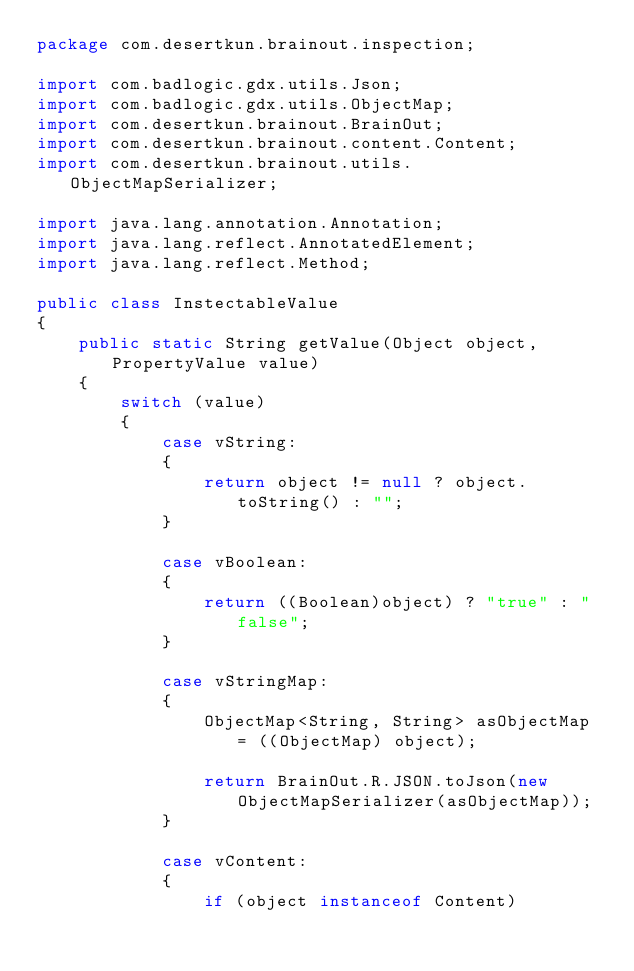<code> <loc_0><loc_0><loc_500><loc_500><_Java_>package com.desertkun.brainout.inspection;

import com.badlogic.gdx.utils.Json;
import com.badlogic.gdx.utils.ObjectMap;
import com.desertkun.brainout.BrainOut;
import com.desertkun.brainout.content.Content;
import com.desertkun.brainout.utils.ObjectMapSerializer;

import java.lang.annotation.Annotation;
import java.lang.reflect.AnnotatedElement;
import java.lang.reflect.Method;

public class InstectableValue
{
    public static String getValue(Object object, PropertyValue value)
    {
        switch (value)
        {
            case vString:
            {
                return object != null ? object.toString() : "";
            }

            case vBoolean:
            {
                return ((Boolean)object) ? "true" : "false";
            }

            case vStringMap:
            {
                ObjectMap<String, String> asObjectMap = ((ObjectMap) object);

                return BrainOut.R.JSON.toJson(new ObjectMapSerializer(asObjectMap));
            }

            case vContent:
            {
                if (object instanceof Content)</code> 